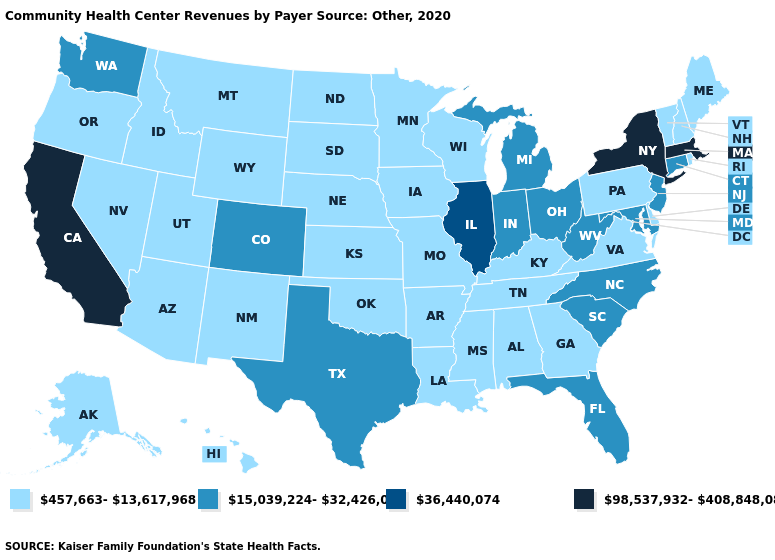Which states hav the highest value in the West?
Be succinct. California. What is the value of Missouri?
Write a very short answer. 457,663-13,617,968. Name the states that have a value in the range 457,663-13,617,968?
Write a very short answer. Alabama, Alaska, Arizona, Arkansas, Delaware, Georgia, Hawaii, Idaho, Iowa, Kansas, Kentucky, Louisiana, Maine, Minnesota, Mississippi, Missouri, Montana, Nebraska, Nevada, New Hampshire, New Mexico, North Dakota, Oklahoma, Oregon, Pennsylvania, Rhode Island, South Dakota, Tennessee, Utah, Vermont, Virginia, Wisconsin, Wyoming. Does Florida have a lower value than Massachusetts?
Short answer required. Yes. What is the value of California?
Keep it brief. 98,537,932-408,848,083. Name the states that have a value in the range 36,440,074?
Keep it brief. Illinois. What is the highest value in the South ?
Write a very short answer. 15,039,224-32,426,095. What is the value of Delaware?
Keep it brief. 457,663-13,617,968. Which states have the lowest value in the Northeast?
Give a very brief answer. Maine, New Hampshire, Pennsylvania, Rhode Island, Vermont. Among the states that border Kentucky , which have the highest value?
Keep it brief. Illinois. Which states hav the highest value in the Northeast?
Write a very short answer. Massachusetts, New York. Name the states that have a value in the range 36,440,074?
Give a very brief answer. Illinois. Name the states that have a value in the range 15,039,224-32,426,095?
Give a very brief answer. Colorado, Connecticut, Florida, Indiana, Maryland, Michigan, New Jersey, North Carolina, Ohio, South Carolina, Texas, Washington, West Virginia. Which states have the lowest value in the South?
Be succinct. Alabama, Arkansas, Delaware, Georgia, Kentucky, Louisiana, Mississippi, Oklahoma, Tennessee, Virginia. Which states have the lowest value in the USA?
Answer briefly. Alabama, Alaska, Arizona, Arkansas, Delaware, Georgia, Hawaii, Idaho, Iowa, Kansas, Kentucky, Louisiana, Maine, Minnesota, Mississippi, Missouri, Montana, Nebraska, Nevada, New Hampshire, New Mexico, North Dakota, Oklahoma, Oregon, Pennsylvania, Rhode Island, South Dakota, Tennessee, Utah, Vermont, Virginia, Wisconsin, Wyoming. 